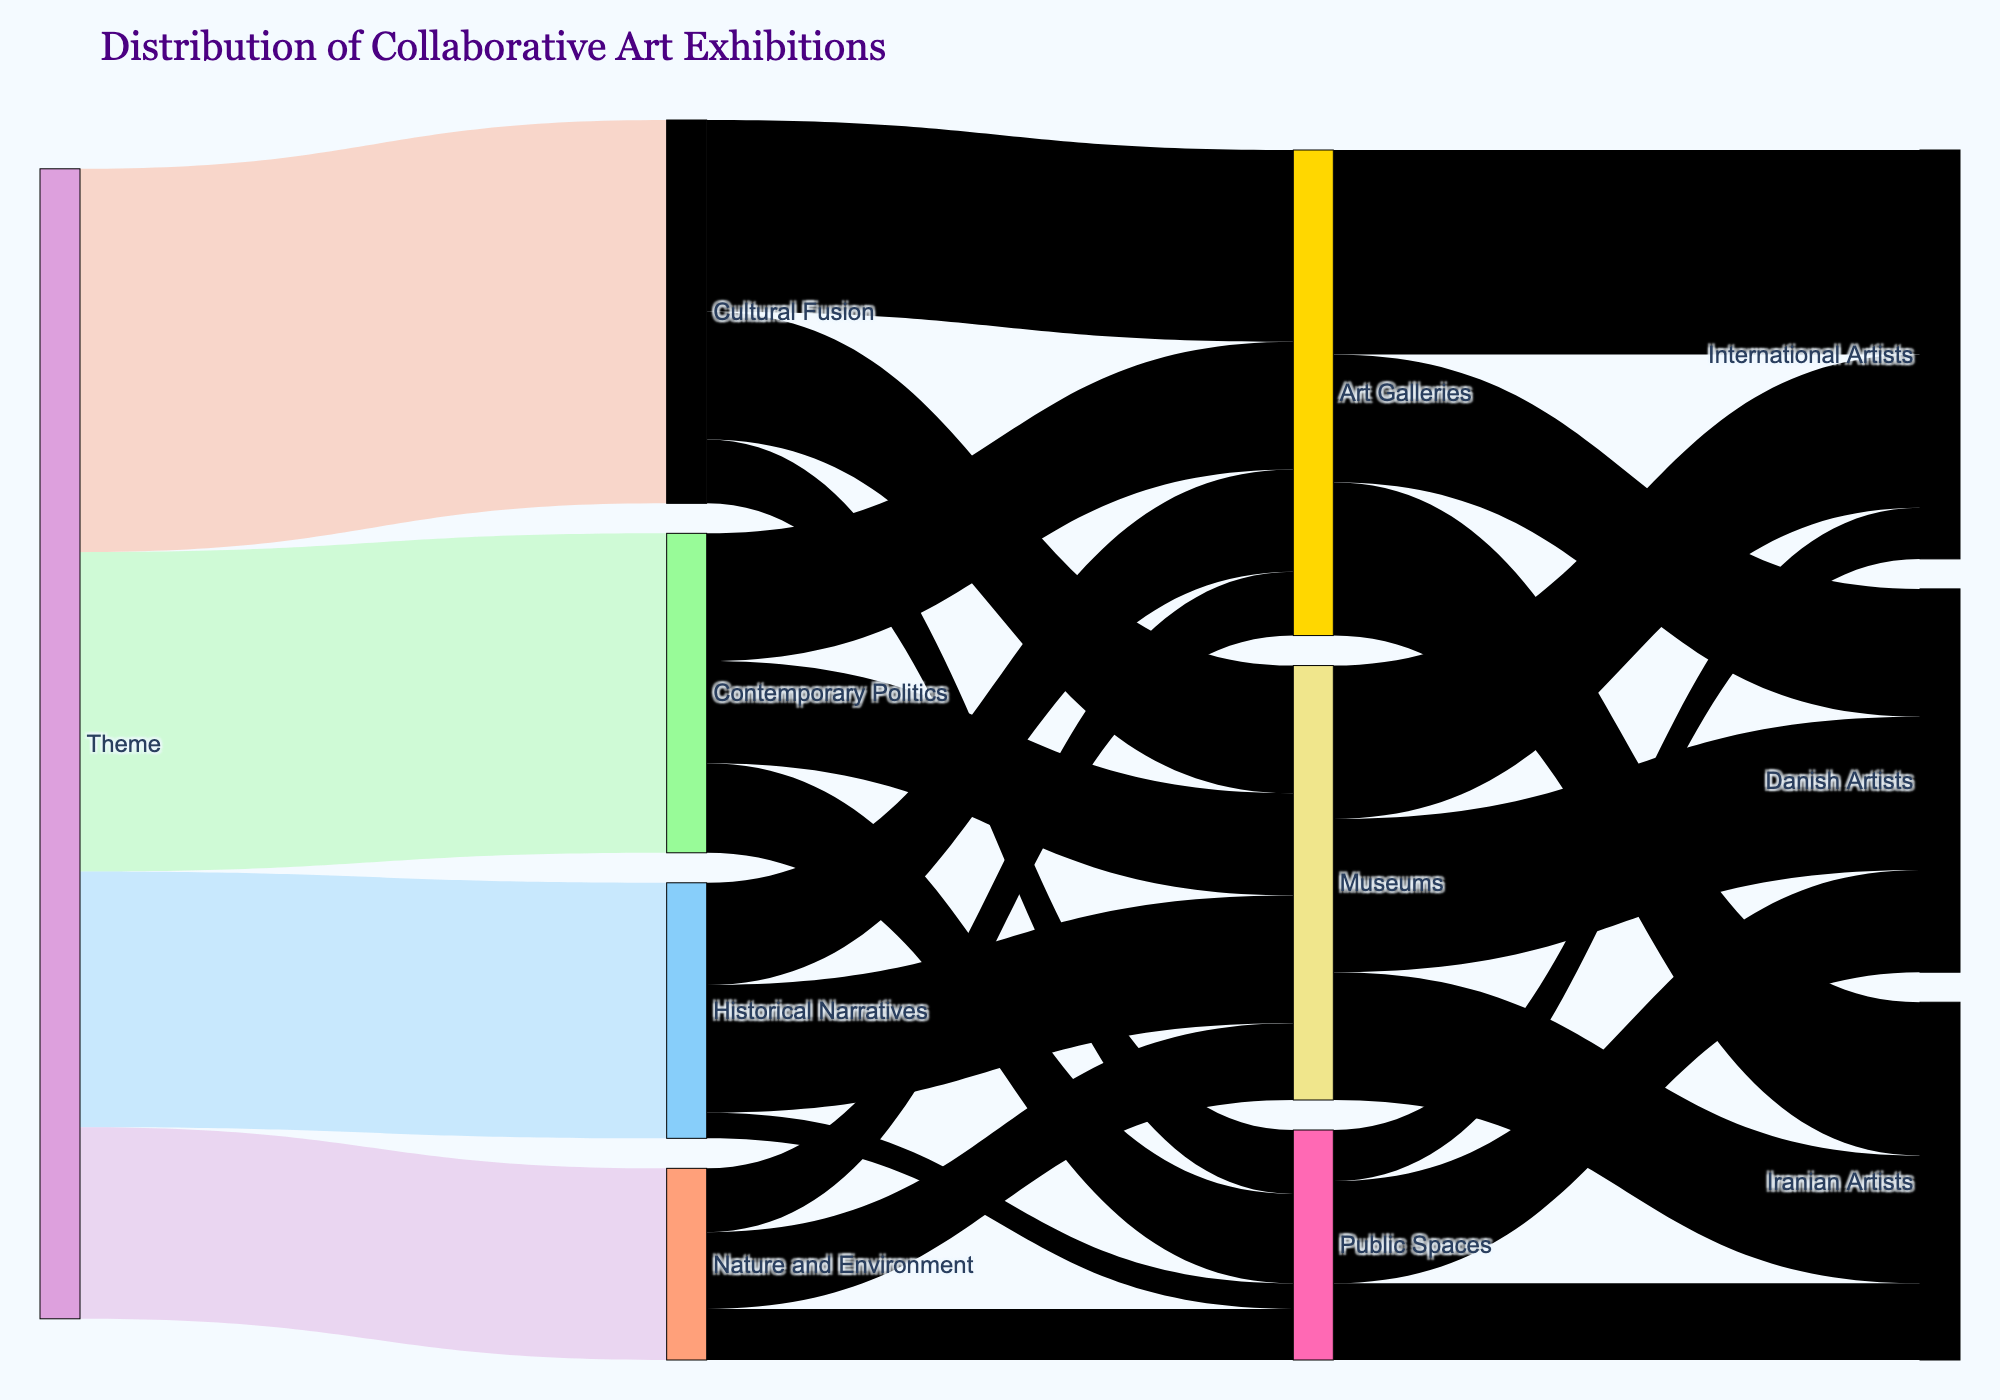What are the themes presented in the Sankey diagram? The Sankey diagram shows four themes: Cultural Fusion, Contemporary Politics, Historical Narratives, and Nature and Environment. This can be directly observed by the starting nodes labeled with these themes.
Answer: Cultural Fusion, Contemporary Politics, Historical Narratives, Nature and Environment Which theme has the highest value of collaborative exhibitions? The value attached to each theme indicates the number of exhibitions. Comparing these values, 'Cultural Fusion' has the highest value at 30.
Answer: Cultural Fusion How many collaborative exhibitions are displayed in Public Spaces according to the diagram? Adding the values for Public Spaces across all themes (Cultural Fusion: 5, Contemporary Politics: 7, Historical Narratives: 2, Nature and Environment: 4), the sum is 5 + 7 + 2 + 4 = 18.
Answer: 18 What is the total number of collaborative exhibitions represented in the diagram? Summing the values associated with each initial theme node: 30 (Cultural Fusion) + 25 (Contemporary Politics) + 20 (Historical Narratives) + 15 (Nature and Environment) = 90.
Answer: 90 Which venue type collaborates most with Danish artists, and what is the value? Inspecting the links from all venue types to Danish Artists: Art Galleries (10), Museums (12), and Public Spaces (8). Museums have the highest value at 12.
Answer: Museums, 12 How many more exhibitions in Museums involve International Artists compared to Iranian Artists? The diagram shows 12 exhibitions in Museums with International Artists and 10 with Iranian Artists. The difference is 12 - 10 = 2.
Answer: 2 more Out of the themes, which one has the least link to Art Galleries, and what is that value? Checking the values of links from themes to Art Galleries: Cultural Fusion (15), Contemporary Politics (10), Historical Narratives (8), and Nature and Environment (5). The least value is from Nature and Environment, which is 5.
Answer: Nature and Environment, 5 What is the ratio of exhibitions in Museums to those in Public Spaces from the theme 'Historical Narratives'? The value for Historical Narratives to Museums is 10, and for Public Spaces it is 2. The ratio is 10:2, simplifying to 5:1.
Answer: 5:1 How many Iranian artists are involved in collaborative exhibitions overall? Summing the values from Iranian artists' links: Art Galleries (12), Museums (10), Public Spaces (6). The total is 12 + 10 + 6 = 28.
Answer: 28 